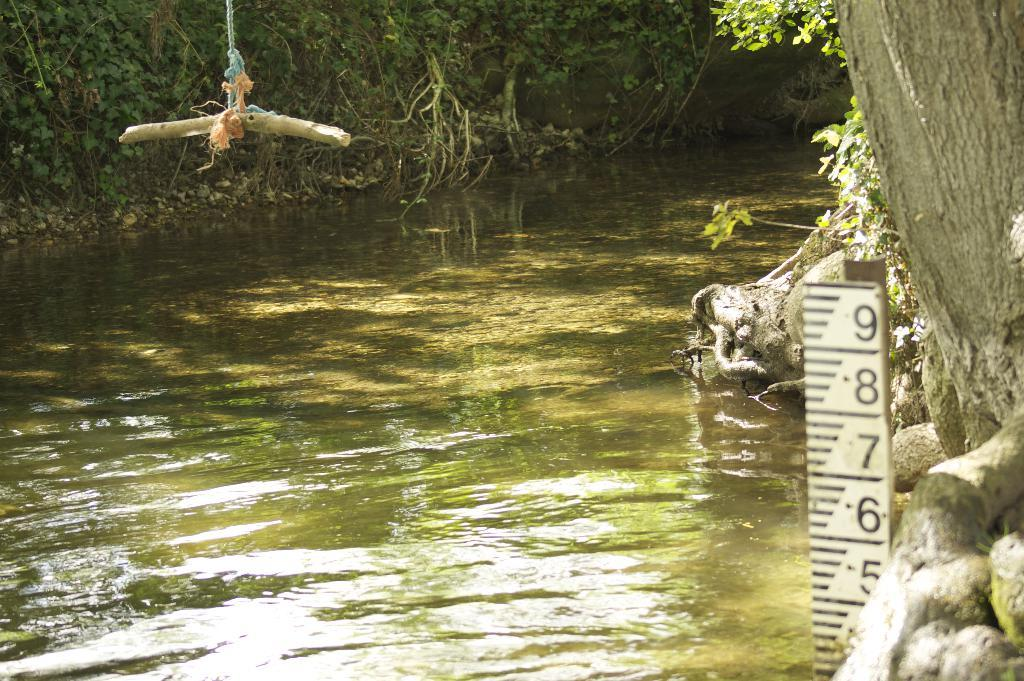What type of vegetation can be seen in the image? There are trees in the image. What natural element is visible in the image besides the trees? There is water visible in the image. What type of string can be seen tied around the trees in the image? There is no string tied around the trees in the image; only trees and water are present. What type of sand can be seen on the shore in the image? There is no shore or sand present in the image; it only features trees and water. 